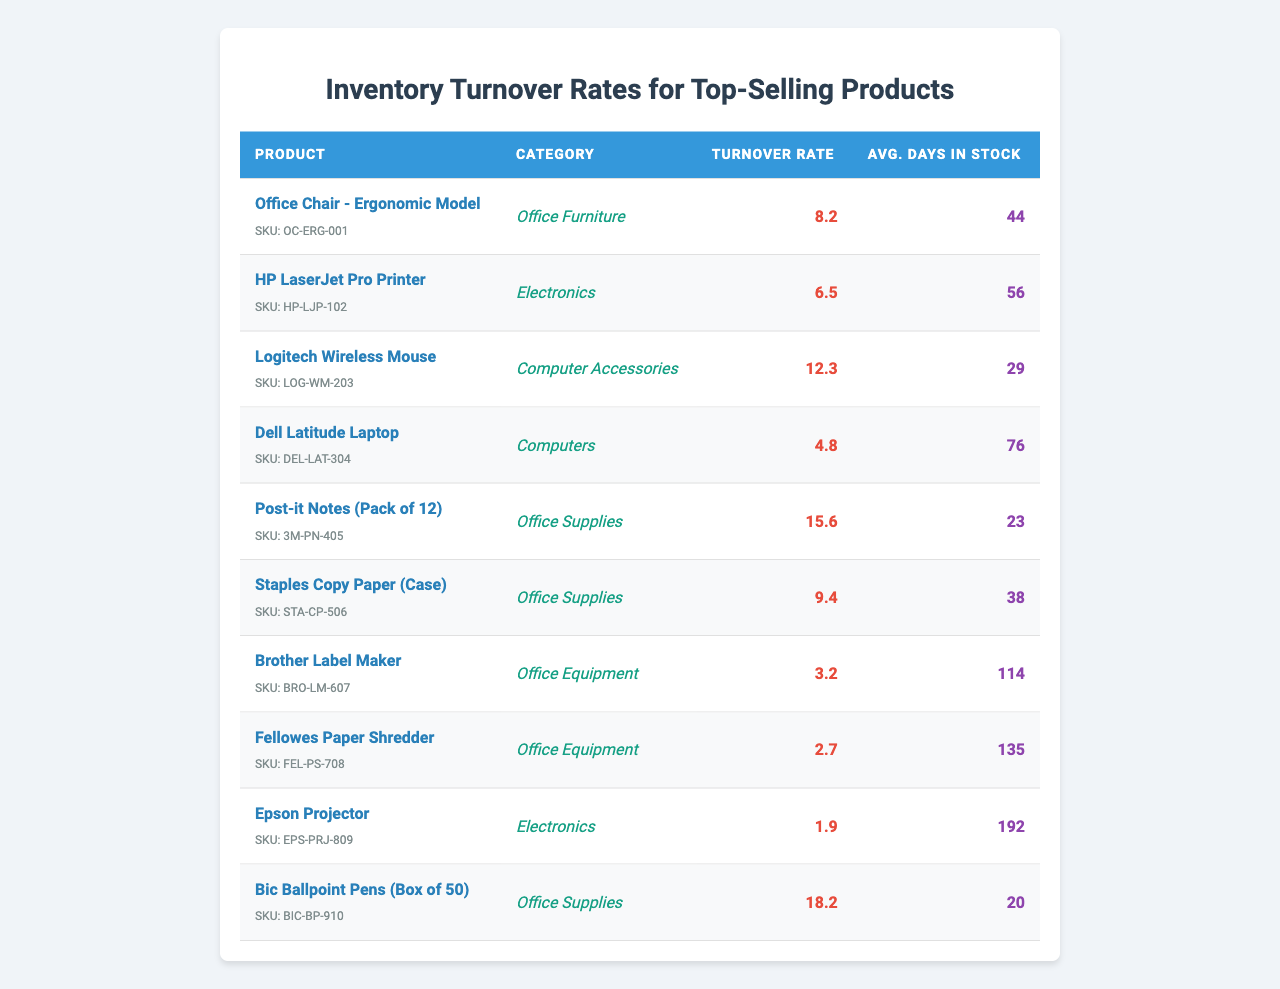What is the turnover rate for the "Logitech Wireless Mouse"? The table shows the turnover rate for each product. For "Logitech Wireless Mouse", it's listed as 12.3.
Answer: 12.3 Which product has the highest turnover rate? By examining the turnover rates listed in the table, "Bic Ballpoint Pens (Box of 50)" has the highest turnover rate at 18.2.
Answer: Bic Ballpoint Pens (Box of 50) How many products have a turnover rate greater than 10? I can count the products with turnover rates from the table. The products are "Logitech Wireless Mouse," "Post-it Notes (Pack of 12)," and "Bic Ballpoint Pens (Box of 50)." In total, there are 3 products.
Answer: 3 What is the average turnover rate of all products listed? To find the average, add all the turnover rates (8.2 + 6.5 + 12.3 + 4.8 + 15.6 + 9.4 + 3.2 + 2.7 + 1.9 + 18.2) = 82.8. There are 10 products, so the average is 82.8 / 10 = 8.28.
Answer: 8.3 What is the average number of days in stock for products in the "Office Supplies" category? For "Office Supplies," the products are "Post-it Notes (Pack of 12)" (23 days), "Staples Copy Paper (Case)" (38 days), and "Bic Ballpoint Pens (Box of 50)" (20 days). The average is (23 + 38 + 20) / 3 = 27 days.
Answer: 27 Is the average days in stock for the "Electronics" category greater than 70? The products in "Electronics" are "HP LaserJet Pro Printer" (56 days) and "Epson Projector" (192 days), averaging (56 + 192) / 2 = 124 days, which is greater than 70.
Answer: Yes Which category has the product with the lowest turnover rate? Looking at the table, "Fellowes Paper Shredder" in the "Office Equipment" category has the lowest turnover rate at 2.7.
Answer: Office Equipment What is the difference between the turnover rates of "HP LaserJet Pro Printer" and "Dell Latitude Laptop"? The turnover rate for "HP LaserJet Pro Printer" is 6.5, and for "Dell Latitude Laptop" it is 4.8. The difference is 6.5 - 4.8 = 1.7.
Answer: 1.7 Do any products have an average days in stock greater than 100? Checking the table, "Brother Label Maker" (114 days) and "Fellowes Paper Shredder" (135 days) both have days in stock greater than 100. Therefore, the answer is Yes.
Answer: Yes How many products have a turnover rate less than 5? The products with a turnover rate less than 5 are "Dell Latitude Laptop" (4.8), "Brother Label Maker" (3.2), "Fellowes Paper Shredder" (2.7), and "Epson Projector" (1.9). There are 4 such products.
Answer: 4 